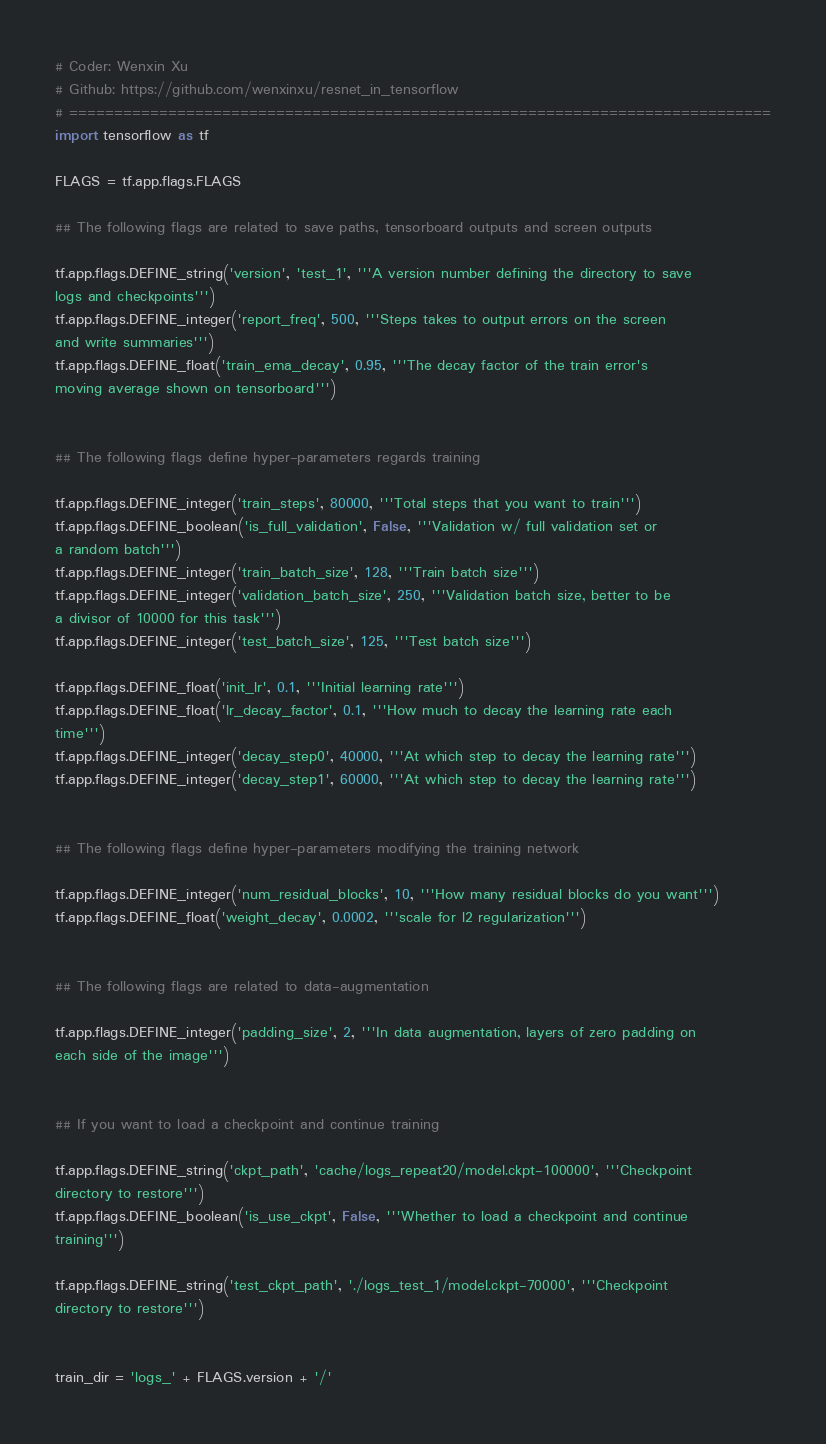<code> <loc_0><loc_0><loc_500><loc_500><_Python_># Coder: Wenxin Xu
# Github: https://github.com/wenxinxu/resnet_in_tensorflow
# ==============================================================================
import tensorflow as tf

FLAGS = tf.app.flags.FLAGS

## The following flags are related to save paths, tensorboard outputs and screen outputs

tf.app.flags.DEFINE_string('version', 'test_1', '''A version number defining the directory to save
logs and checkpoints''')
tf.app.flags.DEFINE_integer('report_freq', 500, '''Steps takes to output errors on the screen
and write summaries''')
tf.app.flags.DEFINE_float('train_ema_decay', 0.95, '''The decay factor of the train error's
moving average shown on tensorboard''')


## The following flags define hyper-parameters regards training

tf.app.flags.DEFINE_integer('train_steps', 80000, '''Total steps that you want to train''')
tf.app.flags.DEFINE_boolean('is_full_validation', False, '''Validation w/ full validation set or
a random batch''')
tf.app.flags.DEFINE_integer('train_batch_size', 128, '''Train batch size''')
tf.app.flags.DEFINE_integer('validation_batch_size', 250, '''Validation batch size, better to be
a divisor of 10000 for this task''')
tf.app.flags.DEFINE_integer('test_batch_size', 125, '''Test batch size''')

tf.app.flags.DEFINE_float('init_lr', 0.1, '''Initial learning rate''')
tf.app.flags.DEFINE_float('lr_decay_factor', 0.1, '''How much to decay the learning rate each
time''')
tf.app.flags.DEFINE_integer('decay_step0', 40000, '''At which step to decay the learning rate''')
tf.app.flags.DEFINE_integer('decay_step1', 60000, '''At which step to decay the learning rate''')


## The following flags define hyper-parameters modifying the training network

tf.app.flags.DEFINE_integer('num_residual_blocks', 10, '''How many residual blocks do you want''')
tf.app.flags.DEFINE_float('weight_decay', 0.0002, '''scale for l2 regularization''')


## The following flags are related to data-augmentation

tf.app.flags.DEFINE_integer('padding_size', 2, '''In data augmentation, layers of zero padding on
each side of the image''')


## If you want to load a checkpoint and continue training

tf.app.flags.DEFINE_string('ckpt_path', 'cache/logs_repeat20/model.ckpt-100000', '''Checkpoint
directory to restore''')
tf.app.flags.DEFINE_boolean('is_use_ckpt', False, '''Whether to load a checkpoint and continue
training''')

tf.app.flags.DEFINE_string('test_ckpt_path', './logs_test_1/model.ckpt-70000', '''Checkpoint
directory to restore''')


train_dir = 'logs_' + FLAGS.version + '/'
</code> 